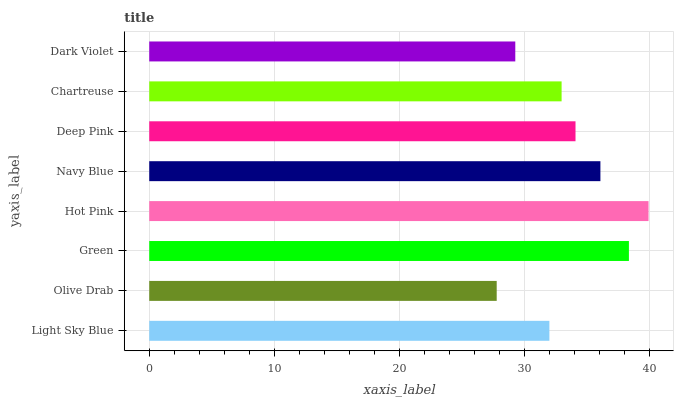Is Olive Drab the minimum?
Answer yes or no. Yes. Is Hot Pink the maximum?
Answer yes or no. Yes. Is Green the minimum?
Answer yes or no. No. Is Green the maximum?
Answer yes or no. No. Is Green greater than Olive Drab?
Answer yes or no. Yes. Is Olive Drab less than Green?
Answer yes or no. Yes. Is Olive Drab greater than Green?
Answer yes or no. No. Is Green less than Olive Drab?
Answer yes or no. No. Is Deep Pink the high median?
Answer yes or no. Yes. Is Chartreuse the low median?
Answer yes or no. Yes. Is Navy Blue the high median?
Answer yes or no. No. Is Light Sky Blue the low median?
Answer yes or no. No. 